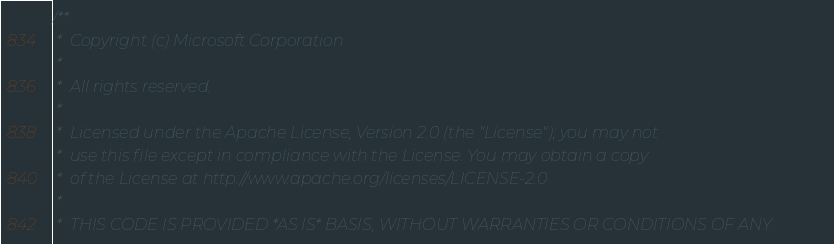<code> <loc_0><loc_0><loc_500><loc_500><_C_>/**
 *  Copyright (c) Microsoft Corporation
 *
 *  All rights reserved.
 *
 *  Licensed under the Apache License, Version 2.0 (the "License"); you may not
 *  use this file except in compliance with the License. You may obtain a copy
 *  of the License at http://www.apache.org/licenses/LICENSE-2.0
 *
 *  THIS CODE IS PROVIDED *AS IS* BASIS, WITHOUT WARRANTIES OR CONDITIONS OF ANY</code> 